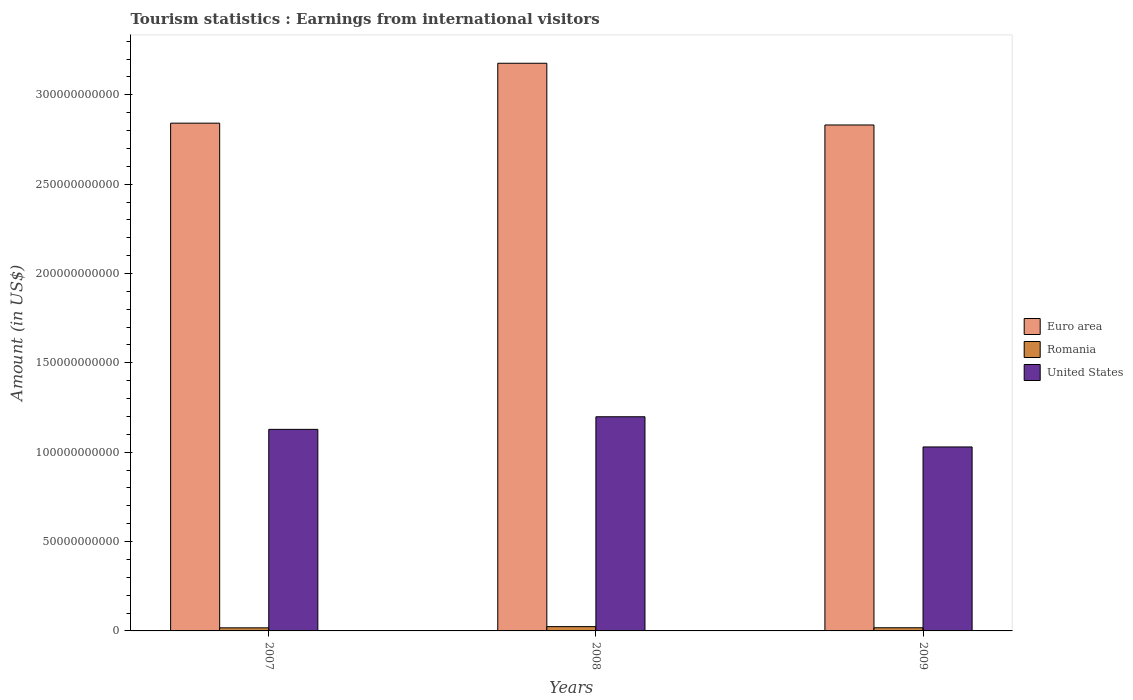How many bars are there on the 1st tick from the left?
Provide a short and direct response. 3. In how many cases, is the number of bars for a given year not equal to the number of legend labels?
Ensure brevity in your answer.  0. What is the earnings from international visitors in Euro area in 2007?
Give a very brief answer. 2.84e+11. Across all years, what is the maximum earnings from international visitors in Romania?
Your response must be concise. 2.41e+09. Across all years, what is the minimum earnings from international visitors in Euro area?
Your answer should be very brief. 2.83e+11. In which year was the earnings from international visitors in Euro area maximum?
Provide a short and direct response. 2008. What is the total earnings from international visitors in United States in the graph?
Offer a terse response. 3.36e+11. What is the difference between the earnings from international visitors in Euro area in 2008 and that in 2009?
Provide a succinct answer. 3.45e+1. What is the difference between the earnings from international visitors in United States in 2008 and the earnings from international visitors in Romania in 2009?
Provide a short and direct response. 1.18e+11. What is the average earnings from international visitors in United States per year?
Ensure brevity in your answer.  1.12e+11. In the year 2008, what is the difference between the earnings from international visitors in United States and earnings from international visitors in Euro area?
Provide a succinct answer. -1.98e+11. What is the ratio of the earnings from international visitors in Euro area in 2007 to that in 2009?
Offer a terse response. 1. Is the earnings from international visitors in Euro area in 2008 less than that in 2009?
Your answer should be compact. No. What is the difference between the highest and the second highest earnings from international visitors in United States?
Ensure brevity in your answer.  7.05e+09. What is the difference between the highest and the lowest earnings from international visitors in Euro area?
Your response must be concise. 3.45e+1. Is the sum of the earnings from international visitors in Euro area in 2007 and 2009 greater than the maximum earnings from international visitors in United States across all years?
Keep it short and to the point. Yes. What does the 1st bar from the left in 2007 represents?
Offer a terse response. Euro area. Is it the case that in every year, the sum of the earnings from international visitors in Euro area and earnings from international visitors in Romania is greater than the earnings from international visitors in United States?
Offer a very short reply. Yes. Are the values on the major ticks of Y-axis written in scientific E-notation?
Ensure brevity in your answer.  No. Does the graph contain grids?
Provide a short and direct response. No. Where does the legend appear in the graph?
Offer a very short reply. Center right. How are the legend labels stacked?
Your answer should be very brief. Vertical. What is the title of the graph?
Offer a very short reply. Tourism statistics : Earnings from international visitors. Does "Italy" appear as one of the legend labels in the graph?
Offer a very short reply. No. What is the label or title of the X-axis?
Keep it short and to the point. Years. What is the label or title of the Y-axis?
Ensure brevity in your answer.  Amount (in US$). What is the Amount (in US$) in Euro area in 2007?
Your answer should be compact. 2.84e+11. What is the Amount (in US$) of Romania in 2007?
Your answer should be compact. 1.72e+09. What is the Amount (in US$) of United States in 2007?
Give a very brief answer. 1.13e+11. What is the Amount (in US$) in Euro area in 2008?
Provide a short and direct response. 3.18e+11. What is the Amount (in US$) in Romania in 2008?
Give a very brief answer. 2.41e+09. What is the Amount (in US$) in United States in 2008?
Keep it short and to the point. 1.20e+11. What is the Amount (in US$) of Euro area in 2009?
Provide a succinct answer. 2.83e+11. What is the Amount (in US$) in Romania in 2009?
Give a very brief answer. 1.77e+09. What is the Amount (in US$) in United States in 2009?
Your response must be concise. 1.03e+11. Across all years, what is the maximum Amount (in US$) in Euro area?
Make the answer very short. 3.18e+11. Across all years, what is the maximum Amount (in US$) of Romania?
Offer a terse response. 2.41e+09. Across all years, what is the maximum Amount (in US$) of United States?
Keep it short and to the point. 1.20e+11. Across all years, what is the minimum Amount (in US$) of Euro area?
Your answer should be very brief. 2.83e+11. Across all years, what is the minimum Amount (in US$) of Romania?
Offer a very short reply. 1.72e+09. Across all years, what is the minimum Amount (in US$) of United States?
Your response must be concise. 1.03e+11. What is the total Amount (in US$) in Euro area in the graph?
Provide a succinct answer. 8.85e+11. What is the total Amount (in US$) of Romania in the graph?
Ensure brevity in your answer.  5.90e+09. What is the total Amount (in US$) in United States in the graph?
Offer a very short reply. 3.36e+11. What is the difference between the Amount (in US$) of Euro area in 2007 and that in 2008?
Your answer should be compact. -3.35e+1. What is the difference between the Amount (in US$) of Romania in 2007 and that in 2008?
Provide a short and direct response. -6.84e+08. What is the difference between the Amount (in US$) of United States in 2007 and that in 2008?
Keep it short and to the point. -7.05e+09. What is the difference between the Amount (in US$) in Euro area in 2007 and that in 2009?
Ensure brevity in your answer.  1.02e+09. What is the difference between the Amount (in US$) in Romania in 2007 and that in 2009?
Your answer should be compact. -4.40e+07. What is the difference between the Amount (in US$) of United States in 2007 and that in 2009?
Give a very brief answer. 9.84e+09. What is the difference between the Amount (in US$) in Euro area in 2008 and that in 2009?
Offer a very short reply. 3.45e+1. What is the difference between the Amount (in US$) of Romania in 2008 and that in 2009?
Offer a very short reply. 6.40e+08. What is the difference between the Amount (in US$) of United States in 2008 and that in 2009?
Provide a short and direct response. 1.69e+1. What is the difference between the Amount (in US$) of Euro area in 2007 and the Amount (in US$) of Romania in 2008?
Offer a very short reply. 2.82e+11. What is the difference between the Amount (in US$) in Euro area in 2007 and the Amount (in US$) in United States in 2008?
Make the answer very short. 1.64e+11. What is the difference between the Amount (in US$) in Romania in 2007 and the Amount (in US$) in United States in 2008?
Your answer should be compact. -1.18e+11. What is the difference between the Amount (in US$) in Euro area in 2007 and the Amount (in US$) in Romania in 2009?
Make the answer very short. 2.82e+11. What is the difference between the Amount (in US$) of Euro area in 2007 and the Amount (in US$) of United States in 2009?
Provide a short and direct response. 1.81e+11. What is the difference between the Amount (in US$) in Romania in 2007 and the Amount (in US$) in United States in 2009?
Keep it short and to the point. -1.01e+11. What is the difference between the Amount (in US$) of Euro area in 2008 and the Amount (in US$) of Romania in 2009?
Ensure brevity in your answer.  3.16e+11. What is the difference between the Amount (in US$) of Euro area in 2008 and the Amount (in US$) of United States in 2009?
Keep it short and to the point. 2.15e+11. What is the difference between the Amount (in US$) of Romania in 2008 and the Amount (in US$) of United States in 2009?
Keep it short and to the point. -1.01e+11. What is the average Amount (in US$) in Euro area per year?
Give a very brief answer. 2.95e+11. What is the average Amount (in US$) of Romania per year?
Make the answer very short. 1.97e+09. What is the average Amount (in US$) in United States per year?
Keep it short and to the point. 1.12e+11. In the year 2007, what is the difference between the Amount (in US$) of Euro area and Amount (in US$) of Romania?
Offer a very short reply. 2.82e+11. In the year 2007, what is the difference between the Amount (in US$) in Euro area and Amount (in US$) in United States?
Your answer should be very brief. 1.71e+11. In the year 2007, what is the difference between the Amount (in US$) in Romania and Amount (in US$) in United States?
Your answer should be very brief. -1.11e+11. In the year 2008, what is the difference between the Amount (in US$) of Euro area and Amount (in US$) of Romania?
Offer a terse response. 3.15e+11. In the year 2008, what is the difference between the Amount (in US$) in Euro area and Amount (in US$) in United States?
Your answer should be very brief. 1.98e+11. In the year 2008, what is the difference between the Amount (in US$) of Romania and Amount (in US$) of United States?
Offer a terse response. -1.17e+11. In the year 2009, what is the difference between the Amount (in US$) of Euro area and Amount (in US$) of Romania?
Ensure brevity in your answer.  2.81e+11. In the year 2009, what is the difference between the Amount (in US$) in Euro area and Amount (in US$) in United States?
Offer a very short reply. 1.80e+11. In the year 2009, what is the difference between the Amount (in US$) of Romania and Amount (in US$) of United States?
Make the answer very short. -1.01e+11. What is the ratio of the Amount (in US$) in Euro area in 2007 to that in 2008?
Ensure brevity in your answer.  0.89. What is the ratio of the Amount (in US$) in Romania in 2007 to that in 2008?
Keep it short and to the point. 0.72. What is the ratio of the Amount (in US$) in United States in 2007 to that in 2008?
Provide a succinct answer. 0.94. What is the ratio of the Amount (in US$) of Romania in 2007 to that in 2009?
Your answer should be compact. 0.98. What is the ratio of the Amount (in US$) of United States in 2007 to that in 2009?
Give a very brief answer. 1.1. What is the ratio of the Amount (in US$) of Euro area in 2008 to that in 2009?
Offer a terse response. 1.12. What is the ratio of the Amount (in US$) in Romania in 2008 to that in 2009?
Give a very brief answer. 1.36. What is the ratio of the Amount (in US$) of United States in 2008 to that in 2009?
Provide a short and direct response. 1.16. What is the difference between the highest and the second highest Amount (in US$) in Euro area?
Offer a terse response. 3.35e+1. What is the difference between the highest and the second highest Amount (in US$) of Romania?
Offer a terse response. 6.40e+08. What is the difference between the highest and the second highest Amount (in US$) in United States?
Your answer should be compact. 7.05e+09. What is the difference between the highest and the lowest Amount (in US$) in Euro area?
Your response must be concise. 3.45e+1. What is the difference between the highest and the lowest Amount (in US$) of Romania?
Offer a terse response. 6.84e+08. What is the difference between the highest and the lowest Amount (in US$) of United States?
Keep it short and to the point. 1.69e+1. 